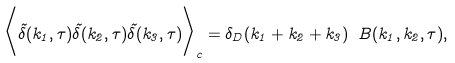<formula> <loc_0><loc_0><loc_500><loc_500>\Big < \tilde { \delta } ( { k } _ { 1 } , \tau ) \tilde { \delta } ( { k } _ { 2 } , \tau ) \tilde { \delta } ( { k } _ { 3 } , \tau ) \Big > _ { c } = \delta _ { D } ( { k } _ { 1 } + { k } _ { 2 } + { k } _ { 3 } ) \ B ( { k } _ { 1 } , { k } _ { 2 } , \tau ) ,</formula> 